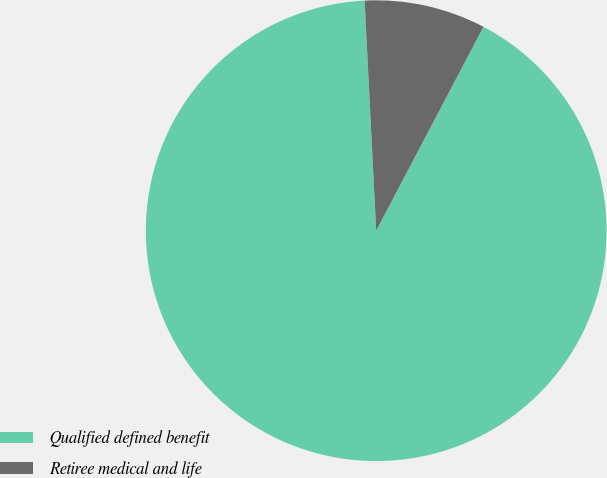Convert chart to OTSL. <chart><loc_0><loc_0><loc_500><loc_500><pie_chart><fcel>Qualified defined benefit<fcel>Retiree medical and life<nl><fcel>91.49%<fcel>8.51%<nl></chart> 